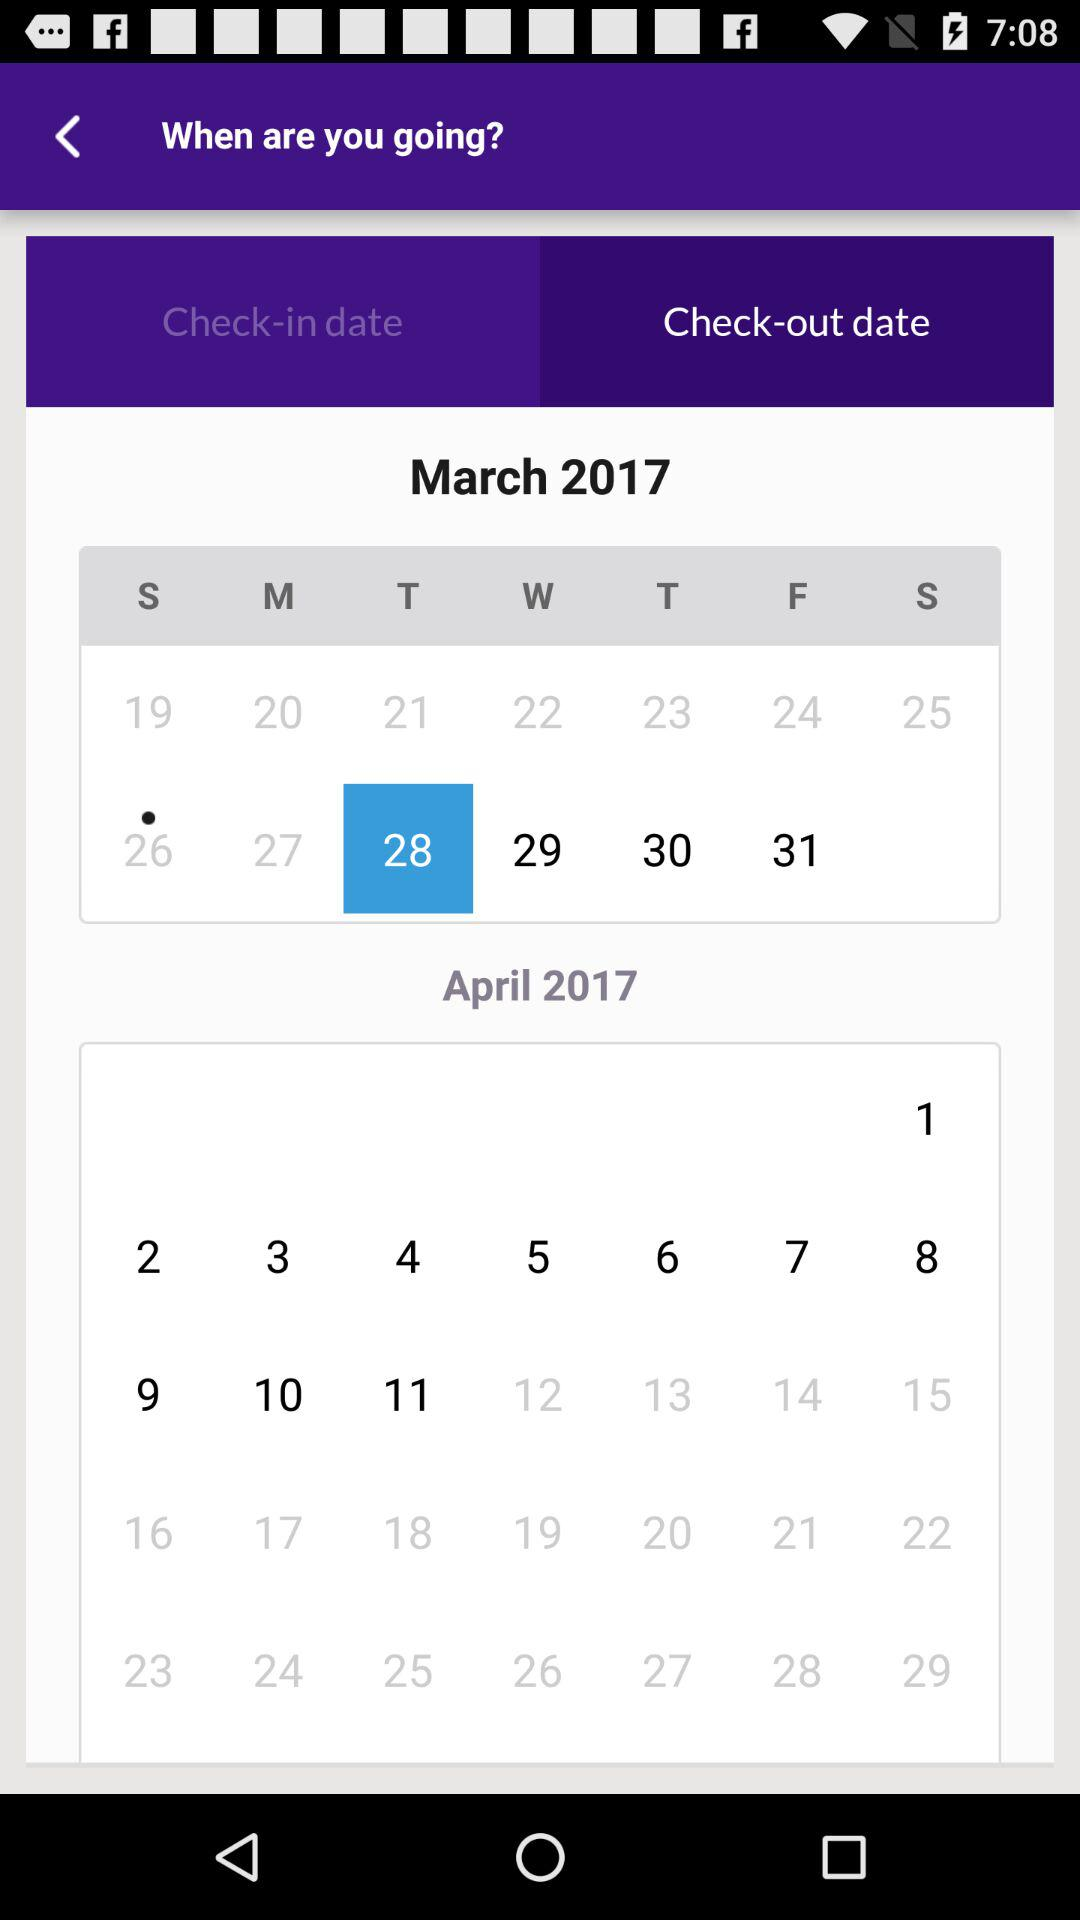Which tab is currently selected? The currently selected tab is "Check-out date". 